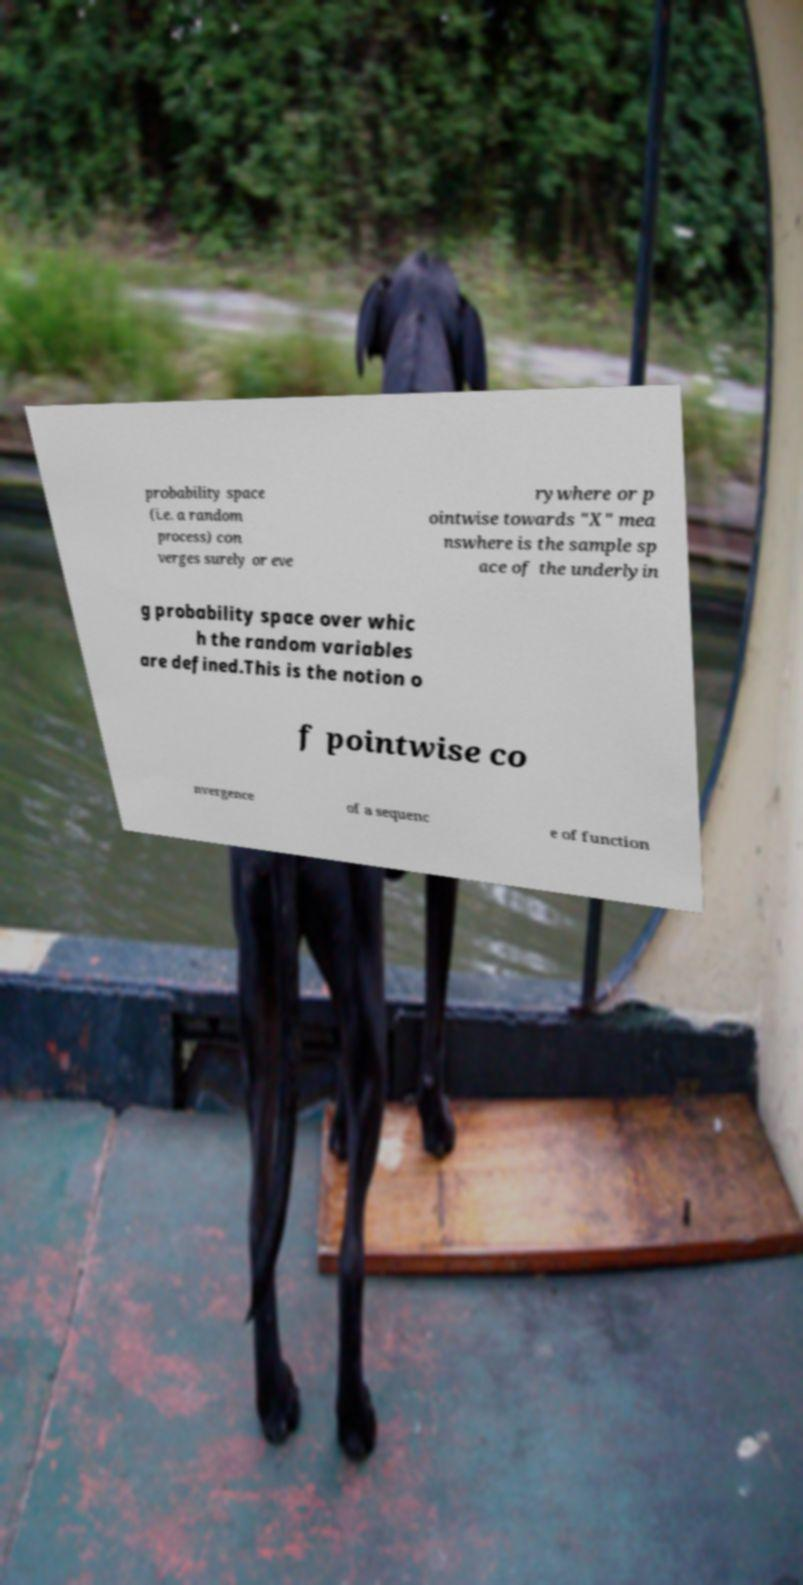Can you read and provide the text displayed in the image?This photo seems to have some interesting text. Can you extract and type it out for me? probability space (i.e. a random process) con verges surely or eve rywhere or p ointwise towards "X" mea nswhere is the sample sp ace of the underlyin g probability space over whic h the random variables are defined.This is the notion o f pointwise co nvergence of a sequenc e of function 